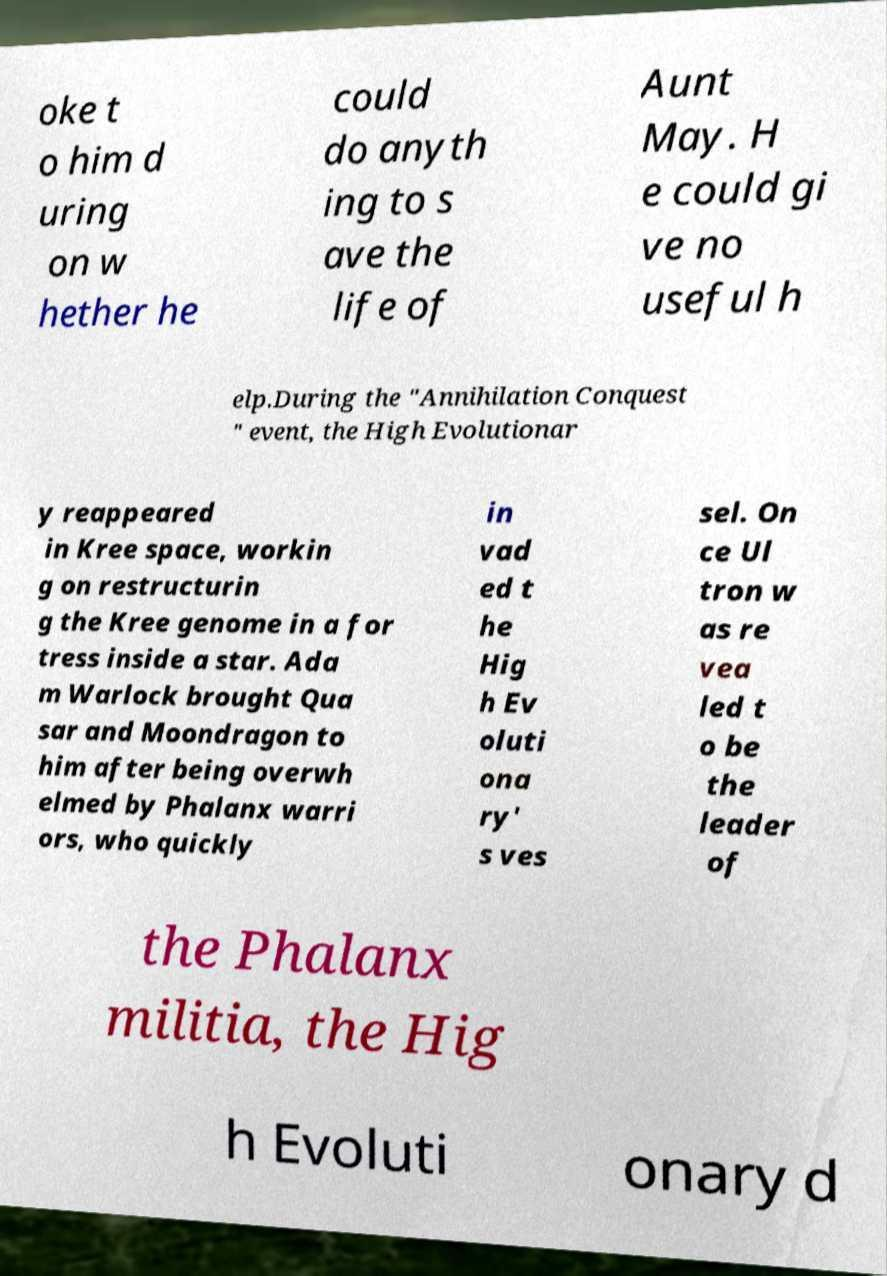Please read and relay the text visible in this image. What does it say? oke t o him d uring on w hether he could do anyth ing to s ave the life of Aunt May. H e could gi ve no useful h elp.During the "Annihilation Conquest " event, the High Evolutionar y reappeared in Kree space, workin g on restructurin g the Kree genome in a for tress inside a star. Ada m Warlock brought Qua sar and Moondragon to him after being overwh elmed by Phalanx warri ors, who quickly in vad ed t he Hig h Ev oluti ona ry' s ves sel. On ce Ul tron w as re vea led t o be the leader of the Phalanx militia, the Hig h Evoluti onary d 